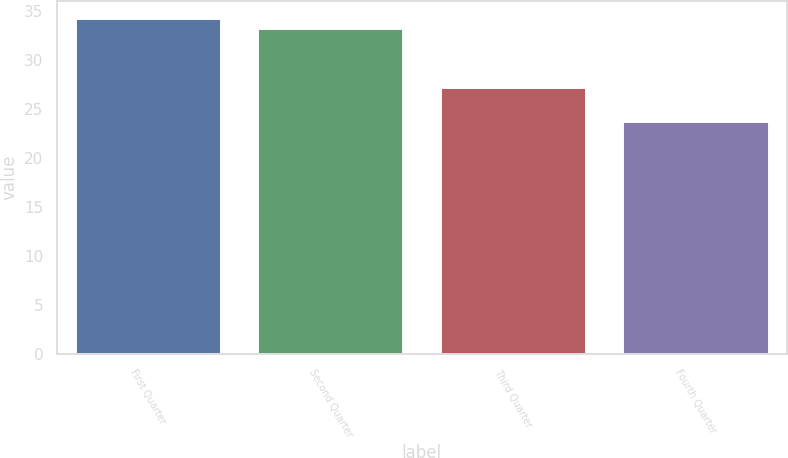Convert chart. <chart><loc_0><loc_0><loc_500><loc_500><bar_chart><fcel>First Quarter<fcel>Second Quarter<fcel>Third Quarter<fcel>Fourth Quarter<nl><fcel>34.25<fcel>33.23<fcel>27.23<fcel>23.72<nl></chart> 